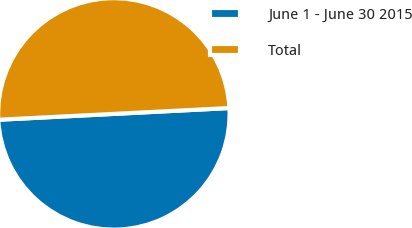<chart> <loc_0><loc_0><loc_500><loc_500><pie_chart><fcel>June 1 - June 30 2015<fcel>Total<nl><fcel>50.0%<fcel>50.0%<nl></chart> 